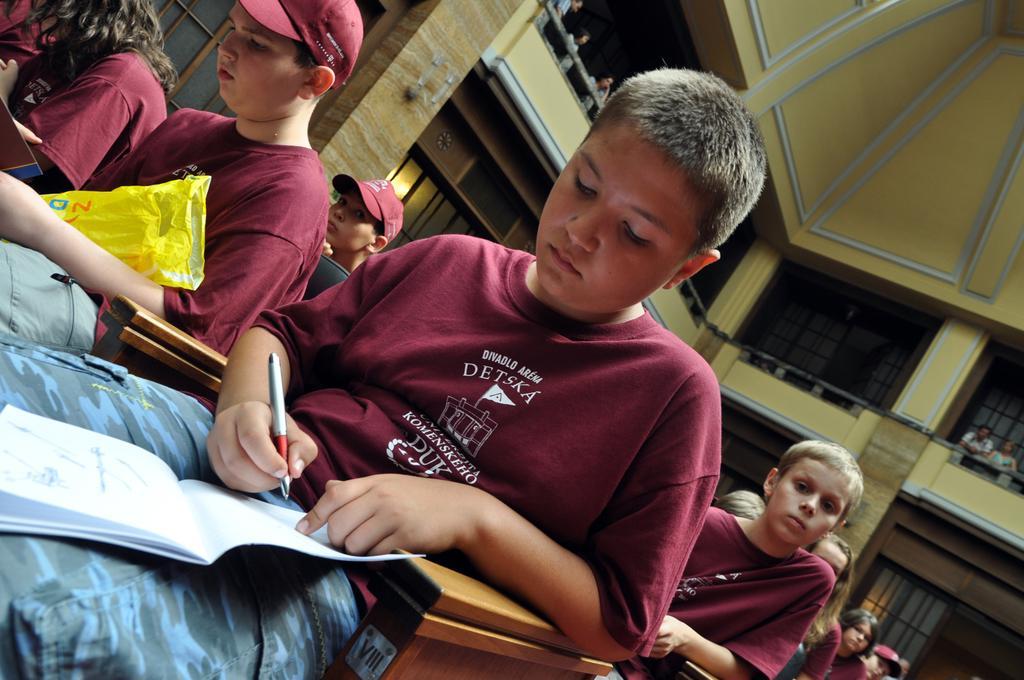In one or two sentences, can you explain what this image depicts? In this image we can see group of children are sitting, and holding a pen and book in the hand, they are wearing the maroon color t-shirt, at the back there are a group of people standing, there are pillars, there is a wall. 